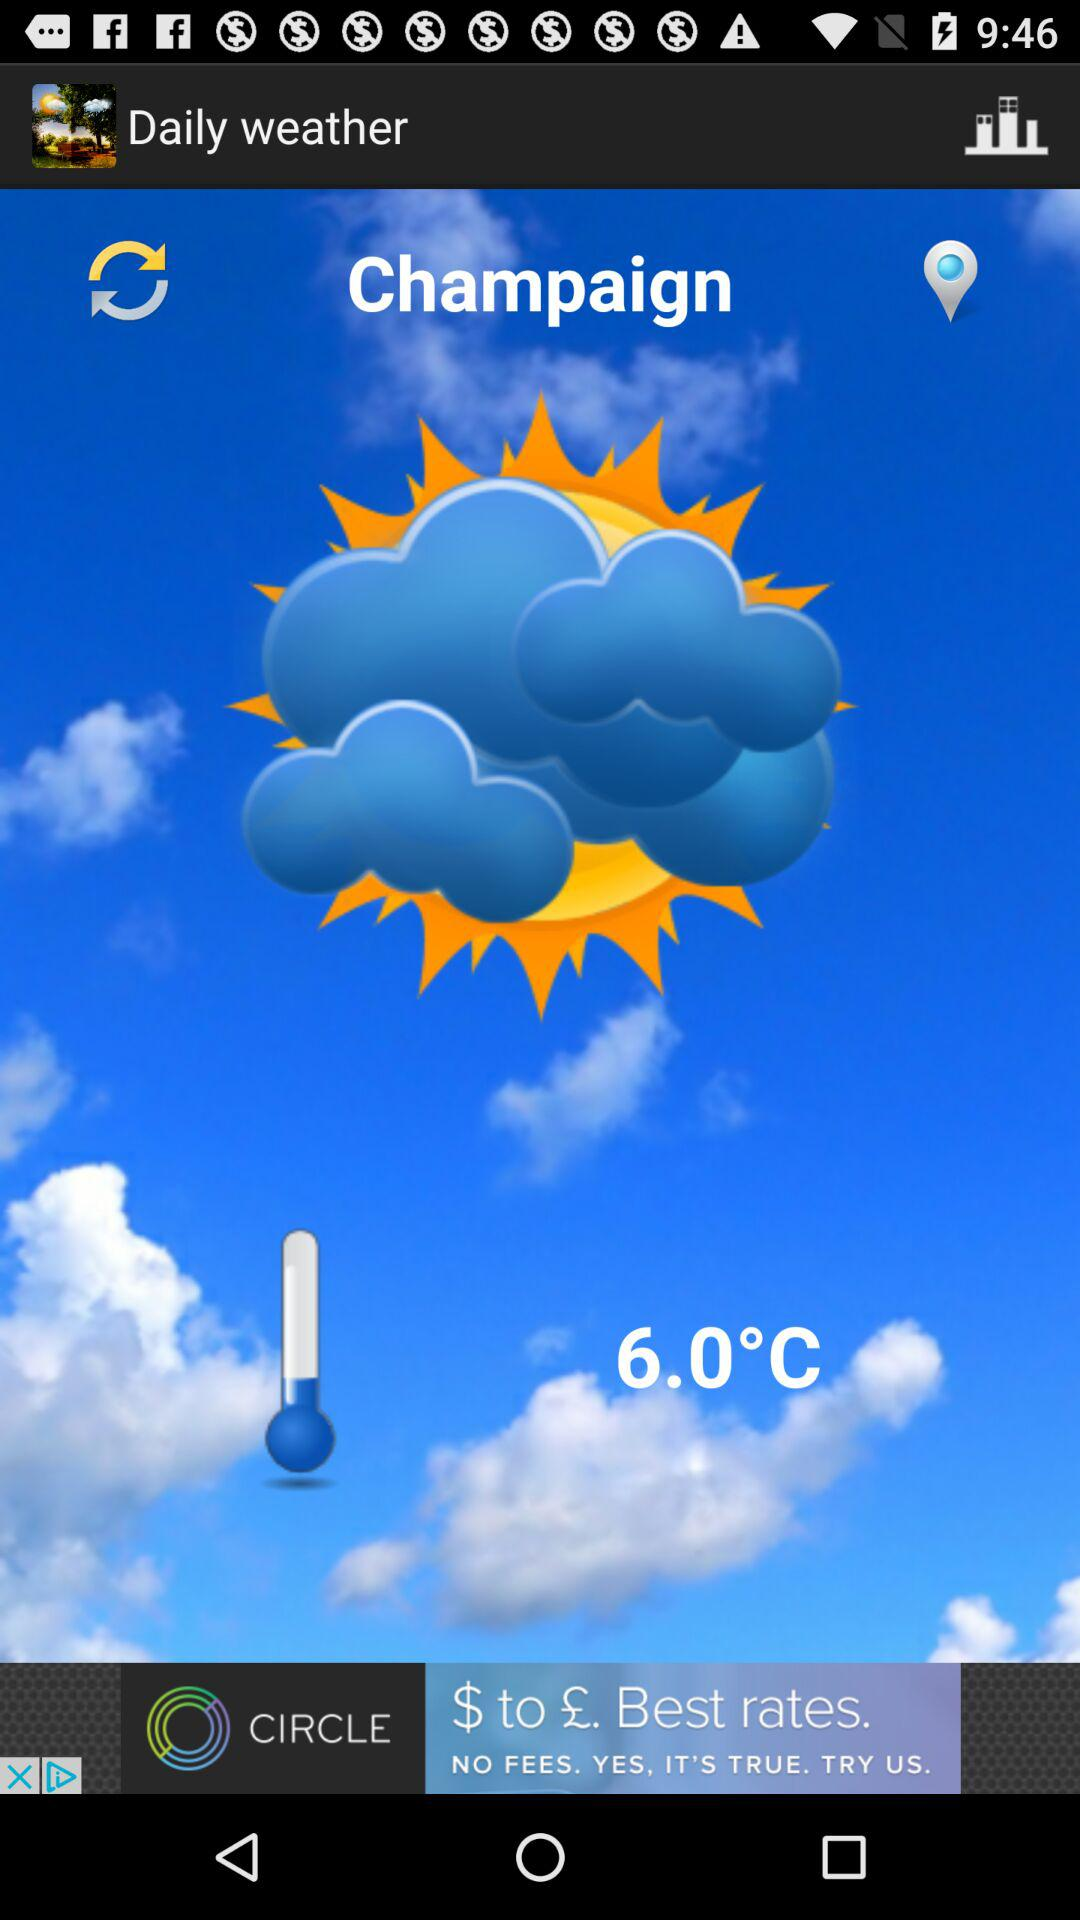What is the temperature shown on the screen? The shown temperature on the screen is 6.0°C. 